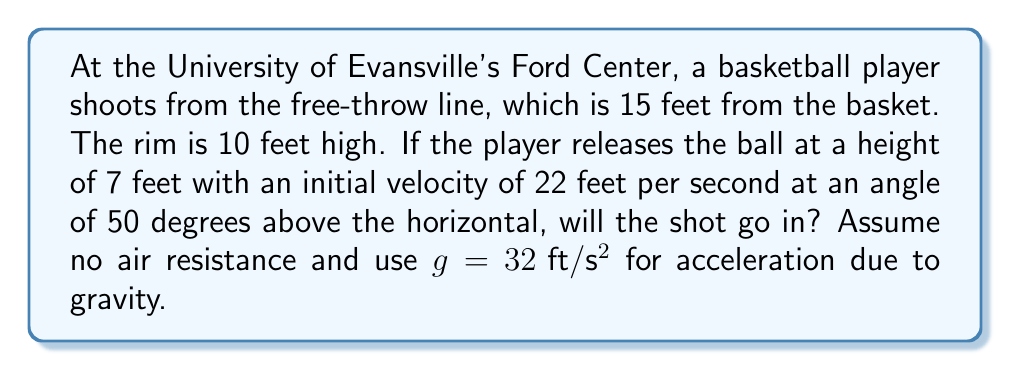Show me your answer to this math problem. Let's approach this step-by-step using projectile motion equations:

1) First, we need to break down the initial velocity into its x and y components:
   $v_{0x} = v_0 \cos \theta = 22 \cos 50° \approx 14.14 \text{ ft}/\text{s}$
   $v_{0y} = v_0 \sin \theta = 22 \sin 50° \approx 16.84 \text{ ft}/\text{s}$

2) The time it takes for the ball to reach the basket horizontally:
   $t = \frac{x}{v_{0x}} = \frac{15}{14.14} \approx 1.06 \text{ s}$

3) Now, we can use the vertical motion equation to find the height of the ball when it reaches the basket:
   $y = y_0 + v_{0y}t - \frac{1}{2}gt^2$
   where $y_0 = 7 \text{ ft}$ (initial height), $t = 1.06 \text{ s}$

4) Plugging in the values:
   $y = 7 + 16.84(1.06) - \frac{1}{2}(32)(1.06)^2$
   $y = 7 + 17.85 - 17.97 \approx 6.88 \text{ ft}$

5) The ball reaches a height of approximately 6.88 feet when it's above the basket.

6) The rim is at 10 feet, so the ball is below the rim when it reaches the basket.

[asy]
import geometry;

size(200);
draw((0,0)--(150,0), arrow=Arrow);
draw((0,0)--(0,120), arrow=Arrow);
draw((0,70)--(150,70), dashed);
draw((0,100)--(150,100), dashed);
draw((150,0)--(150,100));
draw((0,70)..(75,100)..(150,68.8));

label("0", (0,0), SW);
label("15 ft", (150,0), S);
label("7 ft", (0,70), W);
label("10 ft", (0,100), W);
label("6.88 ft", (150,68.8), E);

dot((0,70));
dot((150,68.8));
[/asy]
Answer: No, the shot will not go in. 